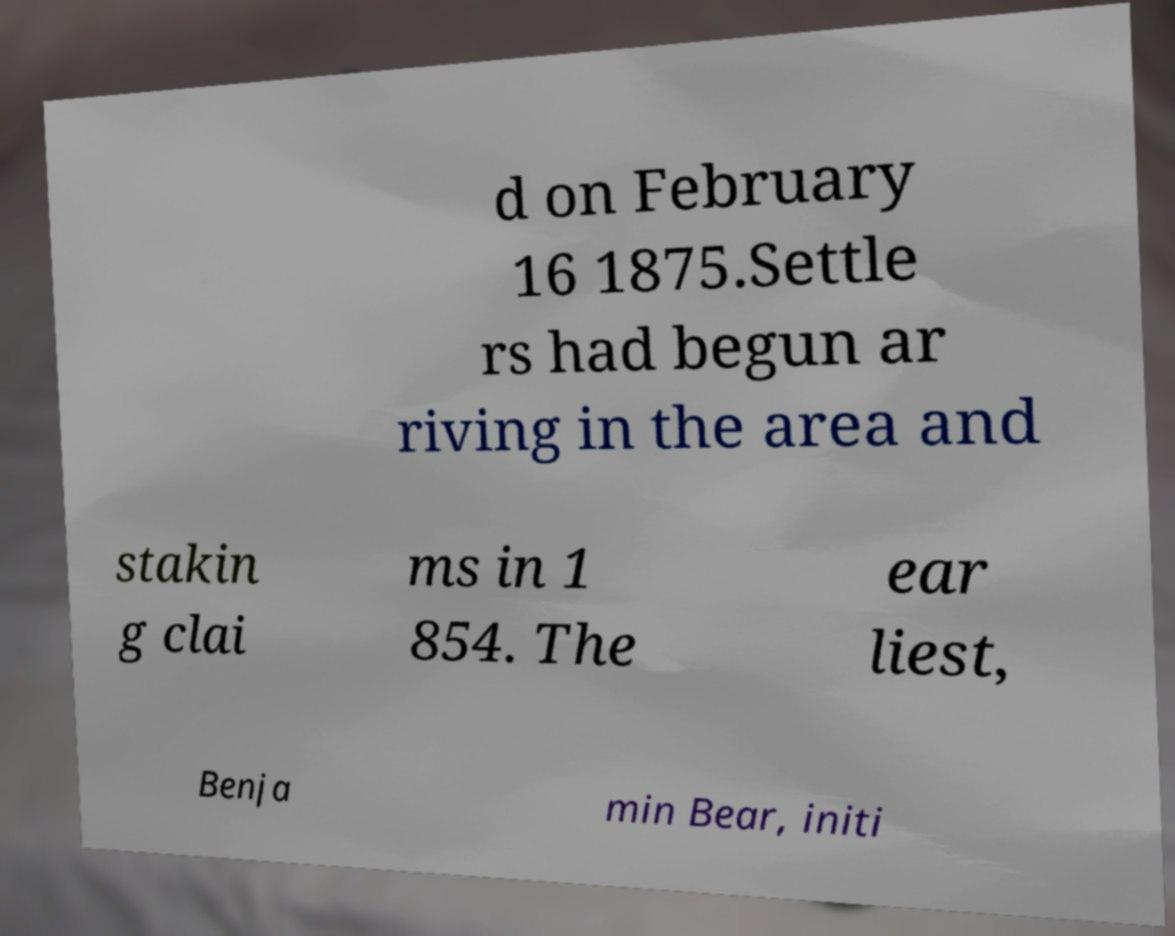I need the written content from this picture converted into text. Can you do that? d on February 16 1875.Settle rs had begun ar riving in the area and stakin g clai ms in 1 854. The ear liest, Benja min Bear, initi 